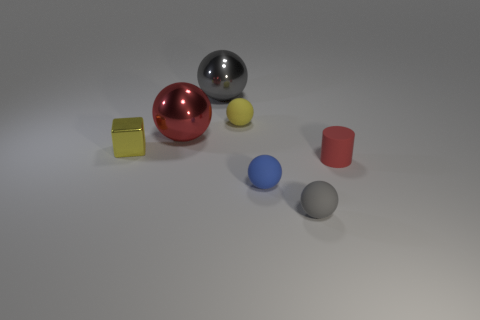The blue object that is made of the same material as the tiny cylinder is what shape?
Offer a terse response. Sphere. There is a small sphere behind the small cylinder; are there any gray spheres in front of it?
Keep it short and to the point. Yes. There is a red thing in front of the large red shiny sphere; is its shape the same as the tiny gray object?
Provide a short and direct response. No. Are there any other things that are the same shape as the gray metal thing?
Provide a short and direct response. Yes. What number of cubes are either big red metallic objects or small red rubber things?
Your response must be concise. 0. What number of purple matte objects are there?
Provide a succinct answer. 0. There is a gray sphere that is in front of the big gray thing on the left side of the blue object; how big is it?
Give a very brief answer. Small. What number of other objects are the same size as the gray shiny sphere?
Make the answer very short. 1. There is a small yellow rubber sphere; how many balls are on the right side of it?
Your answer should be compact. 2. The red metallic sphere is what size?
Provide a short and direct response. Large. 